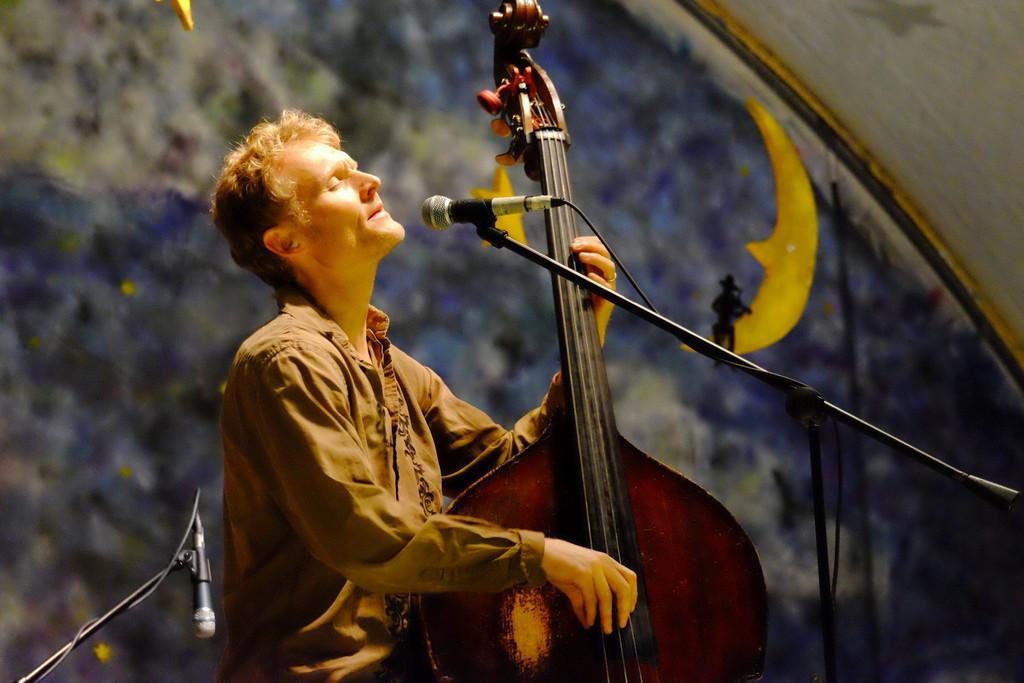What is the main subject of the image? The main subject of the image is a man. What is the man holding in the image? The man is holding a musical instrument. What can be seen behind the man in the image? The man is in front of a mic. Are there any other mics visible in the image? Yes, there is another mic visible in the image. What type of owl can be seen sitting on the man's shoulder in the image? There is no owl present in the image; the man is holding a musical instrument and standing in front of a mic. 